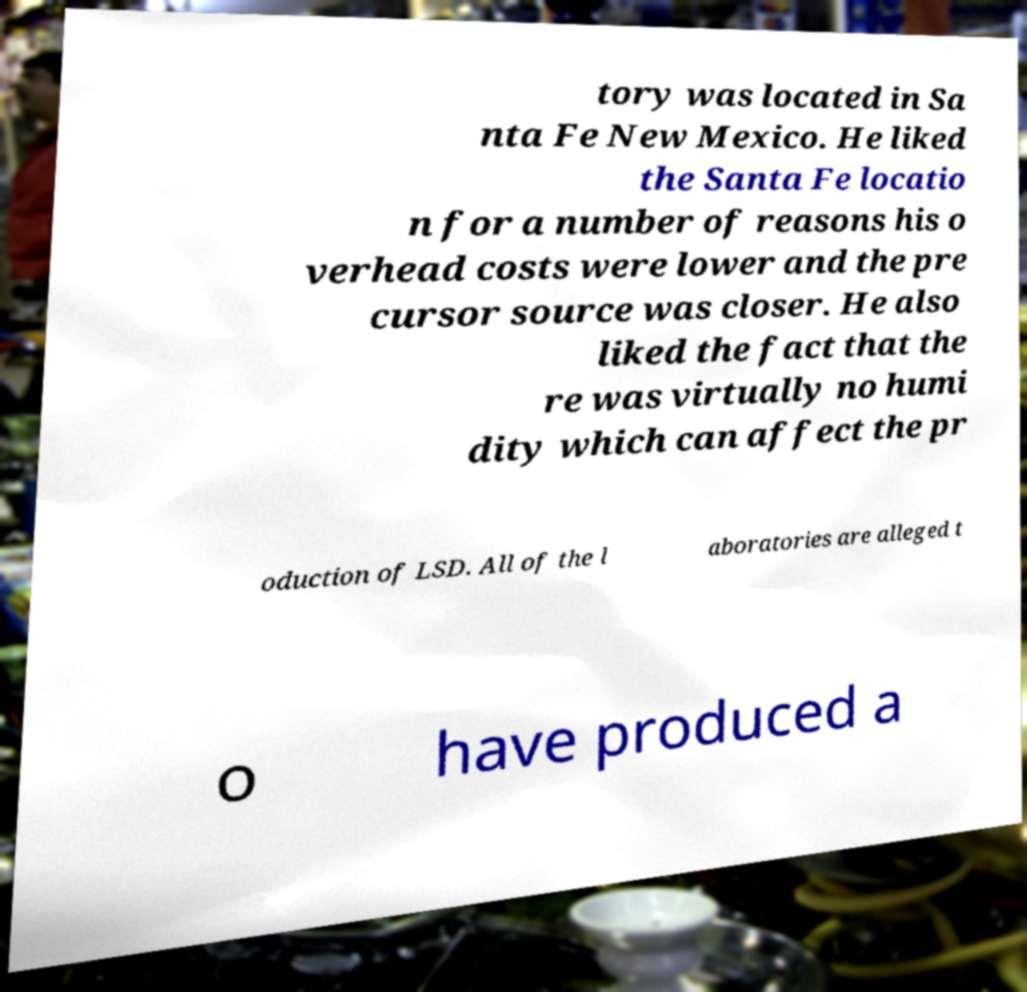Could you assist in decoding the text presented in this image and type it out clearly? tory was located in Sa nta Fe New Mexico. He liked the Santa Fe locatio n for a number of reasons his o verhead costs were lower and the pre cursor source was closer. He also liked the fact that the re was virtually no humi dity which can affect the pr oduction of LSD. All of the l aboratories are alleged t o have produced a 